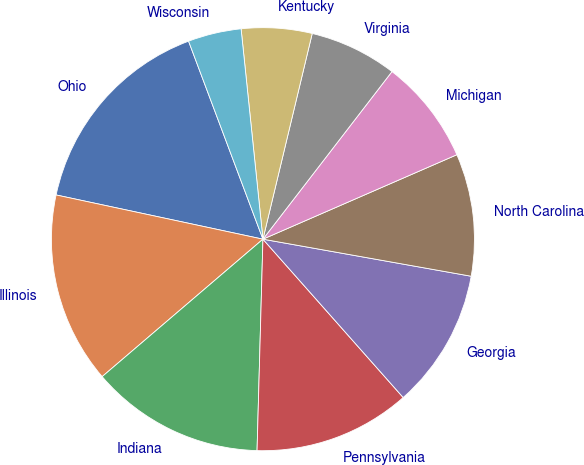Convert chart. <chart><loc_0><loc_0><loc_500><loc_500><pie_chart><fcel>Ohio<fcel>Illinois<fcel>Indiana<fcel>Pennsylvania<fcel>Georgia<fcel>North Carolina<fcel>Michigan<fcel>Virginia<fcel>Kentucky<fcel>Wisconsin<nl><fcel>15.93%<fcel>14.61%<fcel>13.3%<fcel>11.98%<fcel>10.66%<fcel>9.34%<fcel>8.02%<fcel>6.7%<fcel>5.39%<fcel>4.07%<nl></chart> 